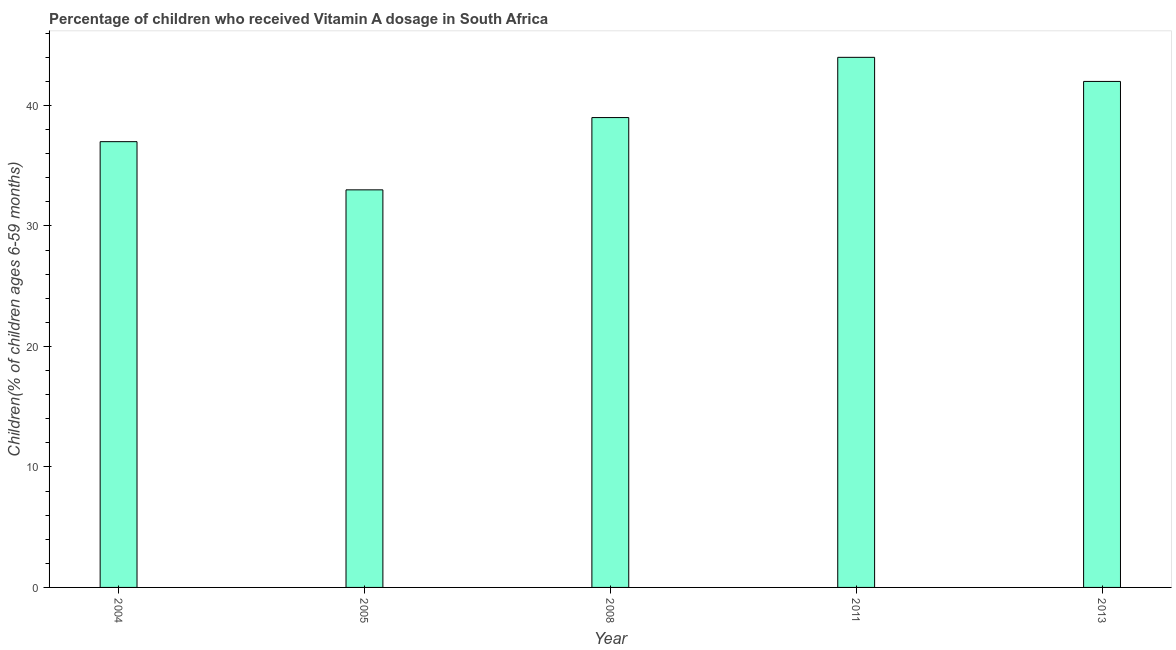Does the graph contain any zero values?
Make the answer very short. No. What is the title of the graph?
Provide a short and direct response. Percentage of children who received Vitamin A dosage in South Africa. What is the label or title of the X-axis?
Offer a very short reply. Year. What is the label or title of the Y-axis?
Offer a very short reply. Children(% of children ages 6-59 months). What is the vitamin a supplementation coverage rate in 2013?
Ensure brevity in your answer.  42. Across all years, what is the maximum vitamin a supplementation coverage rate?
Your answer should be compact. 44. In which year was the vitamin a supplementation coverage rate maximum?
Your answer should be compact. 2011. What is the sum of the vitamin a supplementation coverage rate?
Your response must be concise. 195. What is the difference between the vitamin a supplementation coverage rate in 2005 and 2011?
Your response must be concise. -11. What is the median vitamin a supplementation coverage rate?
Your answer should be compact. 39. Do a majority of the years between 2008 and 2005 (inclusive) have vitamin a supplementation coverage rate greater than 22 %?
Offer a very short reply. No. What is the ratio of the vitamin a supplementation coverage rate in 2005 to that in 2011?
Your answer should be compact. 0.75. Is the difference between the vitamin a supplementation coverage rate in 2004 and 2011 greater than the difference between any two years?
Offer a terse response. No. What is the difference between the highest and the second highest vitamin a supplementation coverage rate?
Ensure brevity in your answer.  2. Is the sum of the vitamin a supplementation coverage rate in 2008 and 2013 greater than the maximum vitamin a supplementation coverage rate across all years?
Provide a succinct answer. Yes. What is the difference between the highest and the lowest vitamin a supplementation coverage rate?
Your response must be concise. 11. How many years are there in the graph?
Offer a terse response. 5. What is the difference between two consecutive major ticks on the Y-axis?
Your answer should be very brief. 10. What is the Children(% of children ages 6-59 months) in 2013?
Your answer should be compact. 42. What is the difference between the Children(% of children ages 6-59 months) in 2004 and 2005?
Your answer should be compact. 4. What is the difference between the Children(% of children ages 6-59 months) in 2004 and 2008?
Your answer should be very brief. -2. What is the difference between the Children(% of children ages 6-59 months) in 2004 and 2011?
Offer a terse response. -7. What is the difference between the Children(% of children ages 6-59 months) in 2005 and 2008?
Ensure brevity in your answer.  -6. What is the difference between the Children(% of children ages 6-59 months) in 2011 and 2013?
Offer a terse response. 2. What is the ratio of the Children(% of children ages 6-59 months) in 2004 to that in 2005?
Give a very brief answer. 1.12. What is the ratio of the Children(% of children ages 6-59 months) in 2004 to that in 2008?
Provide a short and direct response. 0.95. What is the ratio of the Children(% of children ages 6-59 months) in 2004 to that in 2011?
Provide a succinct answer. 0.84. What is the ratio of the Children(% of children ages 6-59 months) in 2004 to that in 2013?
Provide a succinct answer. 0.88. What is the ratio of the Children(% of children ages 6-59 months) in 2005 to that in 2008?
Provide a short and direct response. 0.85. What is the ratio of the Children(% of children ages 6-59 months) in 2005 to that in 2013?
Keep it short and to the point. 0.79. What is the ratio of the Children(% of children ages 6-59 months) in 2008 to that in 2011?
Your answer should be very brief. 0.89. What is the ratio of the Children(% of children ages 6-59 months) in 2008 to that in 2013?
Offer a very short reply. 0.93. What is the ratio of the Children(% of children ages 6-59 months) in 2011 to that in 2013?
Your response must be concise. 1.05. 